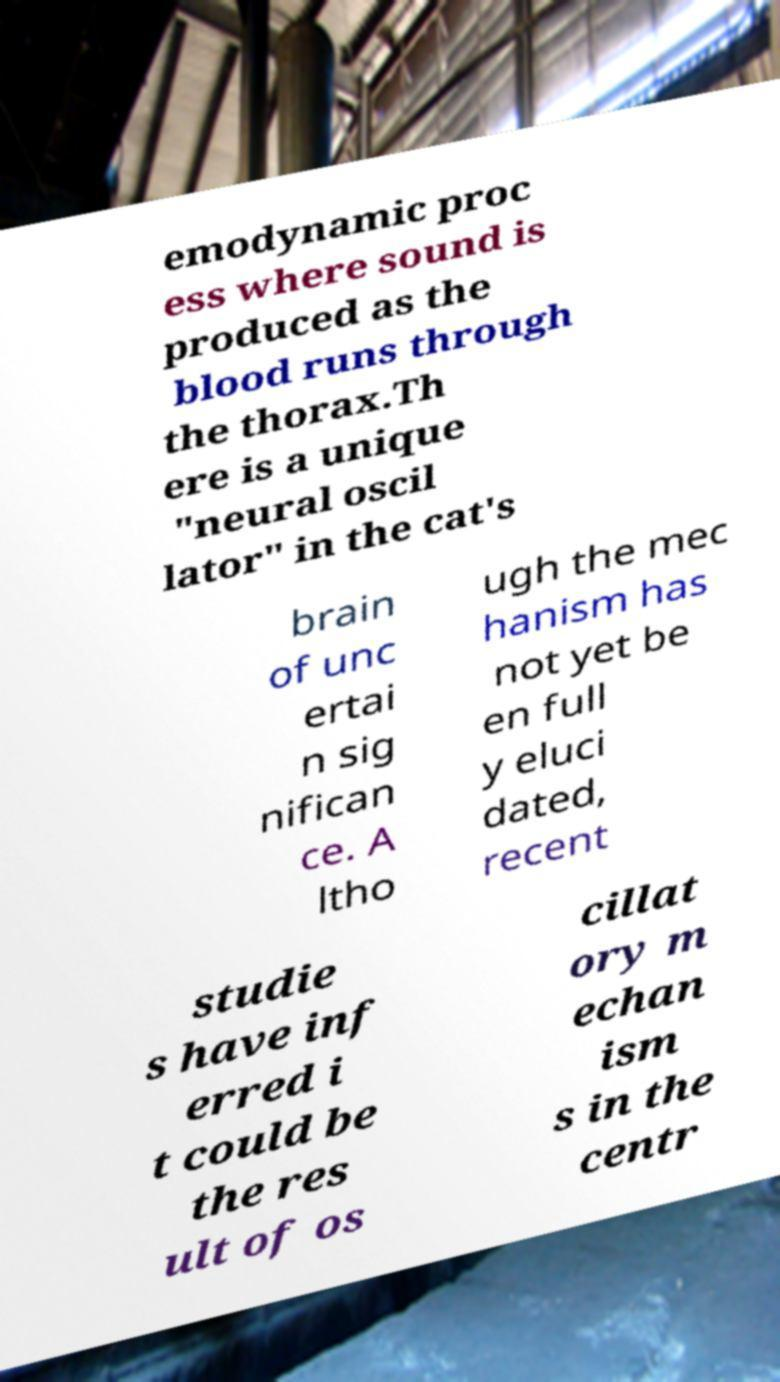What messages or text are displayed in this image? I need them in a readable, typed format. emodynamic proc ess where sound is produced as the blood runs through the thorax.Th ere is a unique "neural oscil lator" in the cat's brain of unc ertai n sig nifican ce. A ltho ugh the mec hanism has not yet be en full y eluci dated, recent studie s have inf erred i t could be the res ult of os cillat ory m echan ism s in the centr 